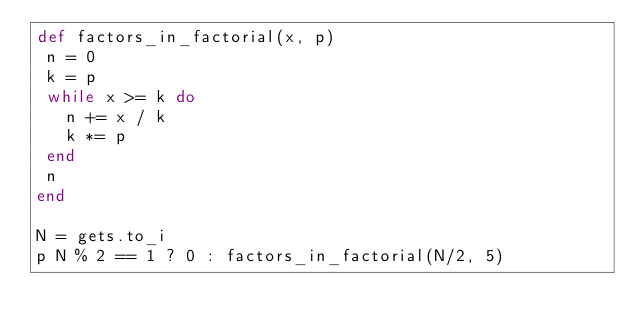Convert code to text. <code><loc_0><loc_0><loc_500><loc_500><_Ruby_>def factors_in_factorial(x, p)
 n = 0
 k = p
 while x >= k do
   n += x / k
   k *= p
 end
 n
end

N = gets.to_i
p N % 2 == 1 ? 0 : factors_in_factorial(N/2, 5)</code> 